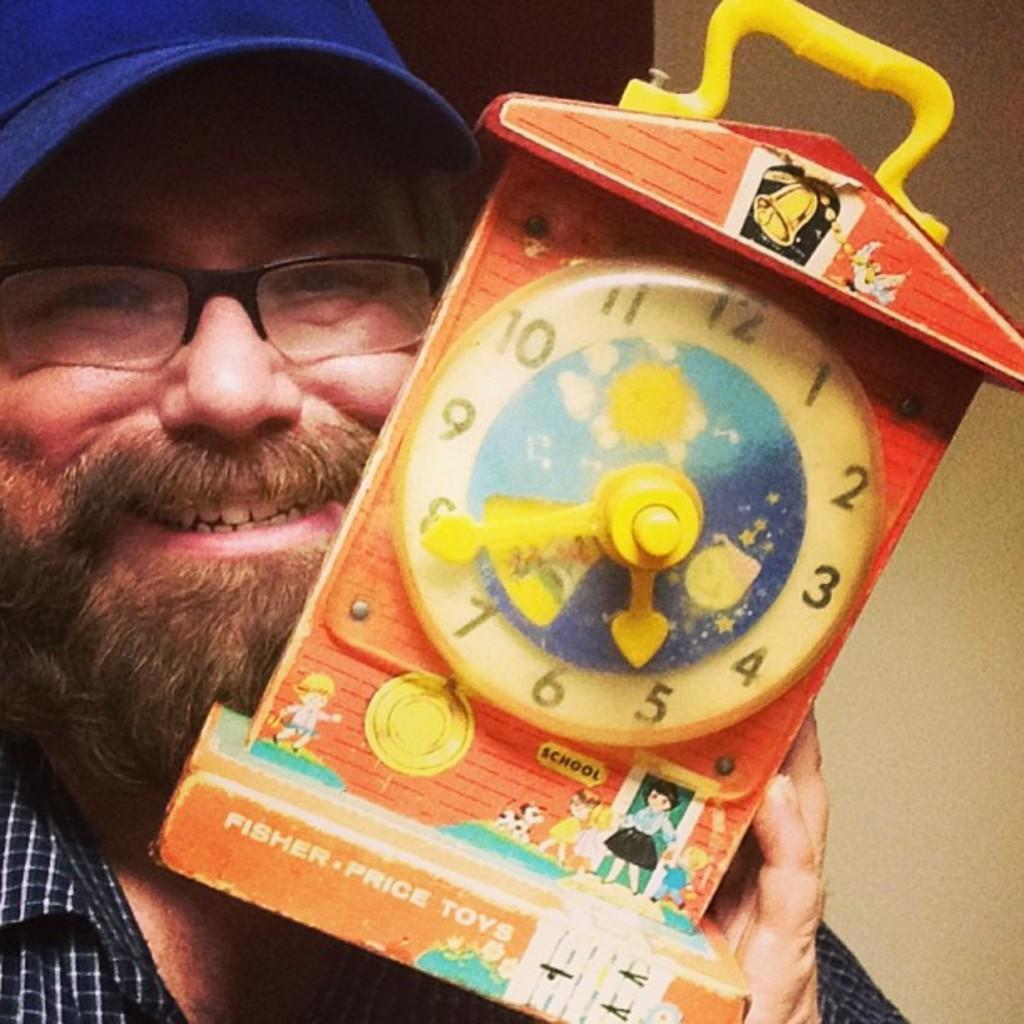Could you give a brief overview of what you see in this image? In this image I can see a man is holding a toy clock, he is wearing a shirt, spectacles and a cap. 